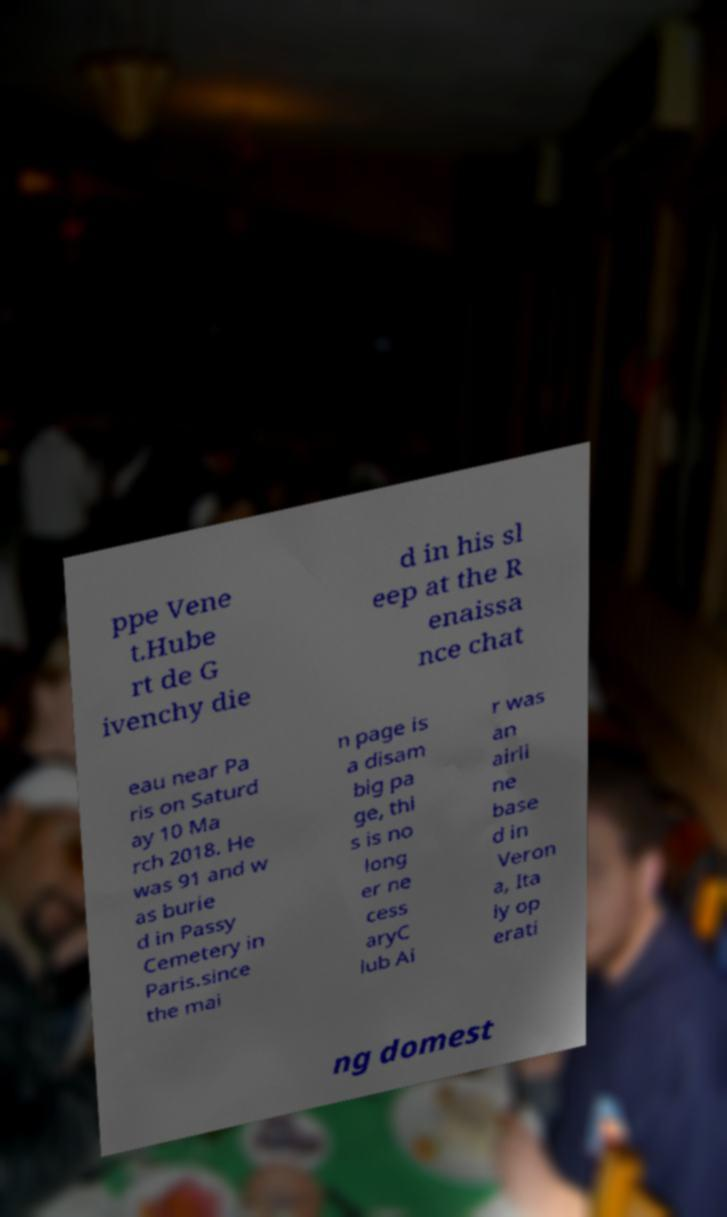Please read and relay the text visible in this image. What does it say? ppe Vene t.Hube rt de G ivenchy die d in his sl eep at the R enaissa nce chat eau near Pa ris on Saturd ay 10 Ma rch 2018. He was 91 and w as burie d in Passy Cemetery in Paris.since the mai n page is a disam big pa ge, thi s is no long er ne cess aryC lub Ai r was an airli ne base d in Veron a, Ita ly op erati ng domest 